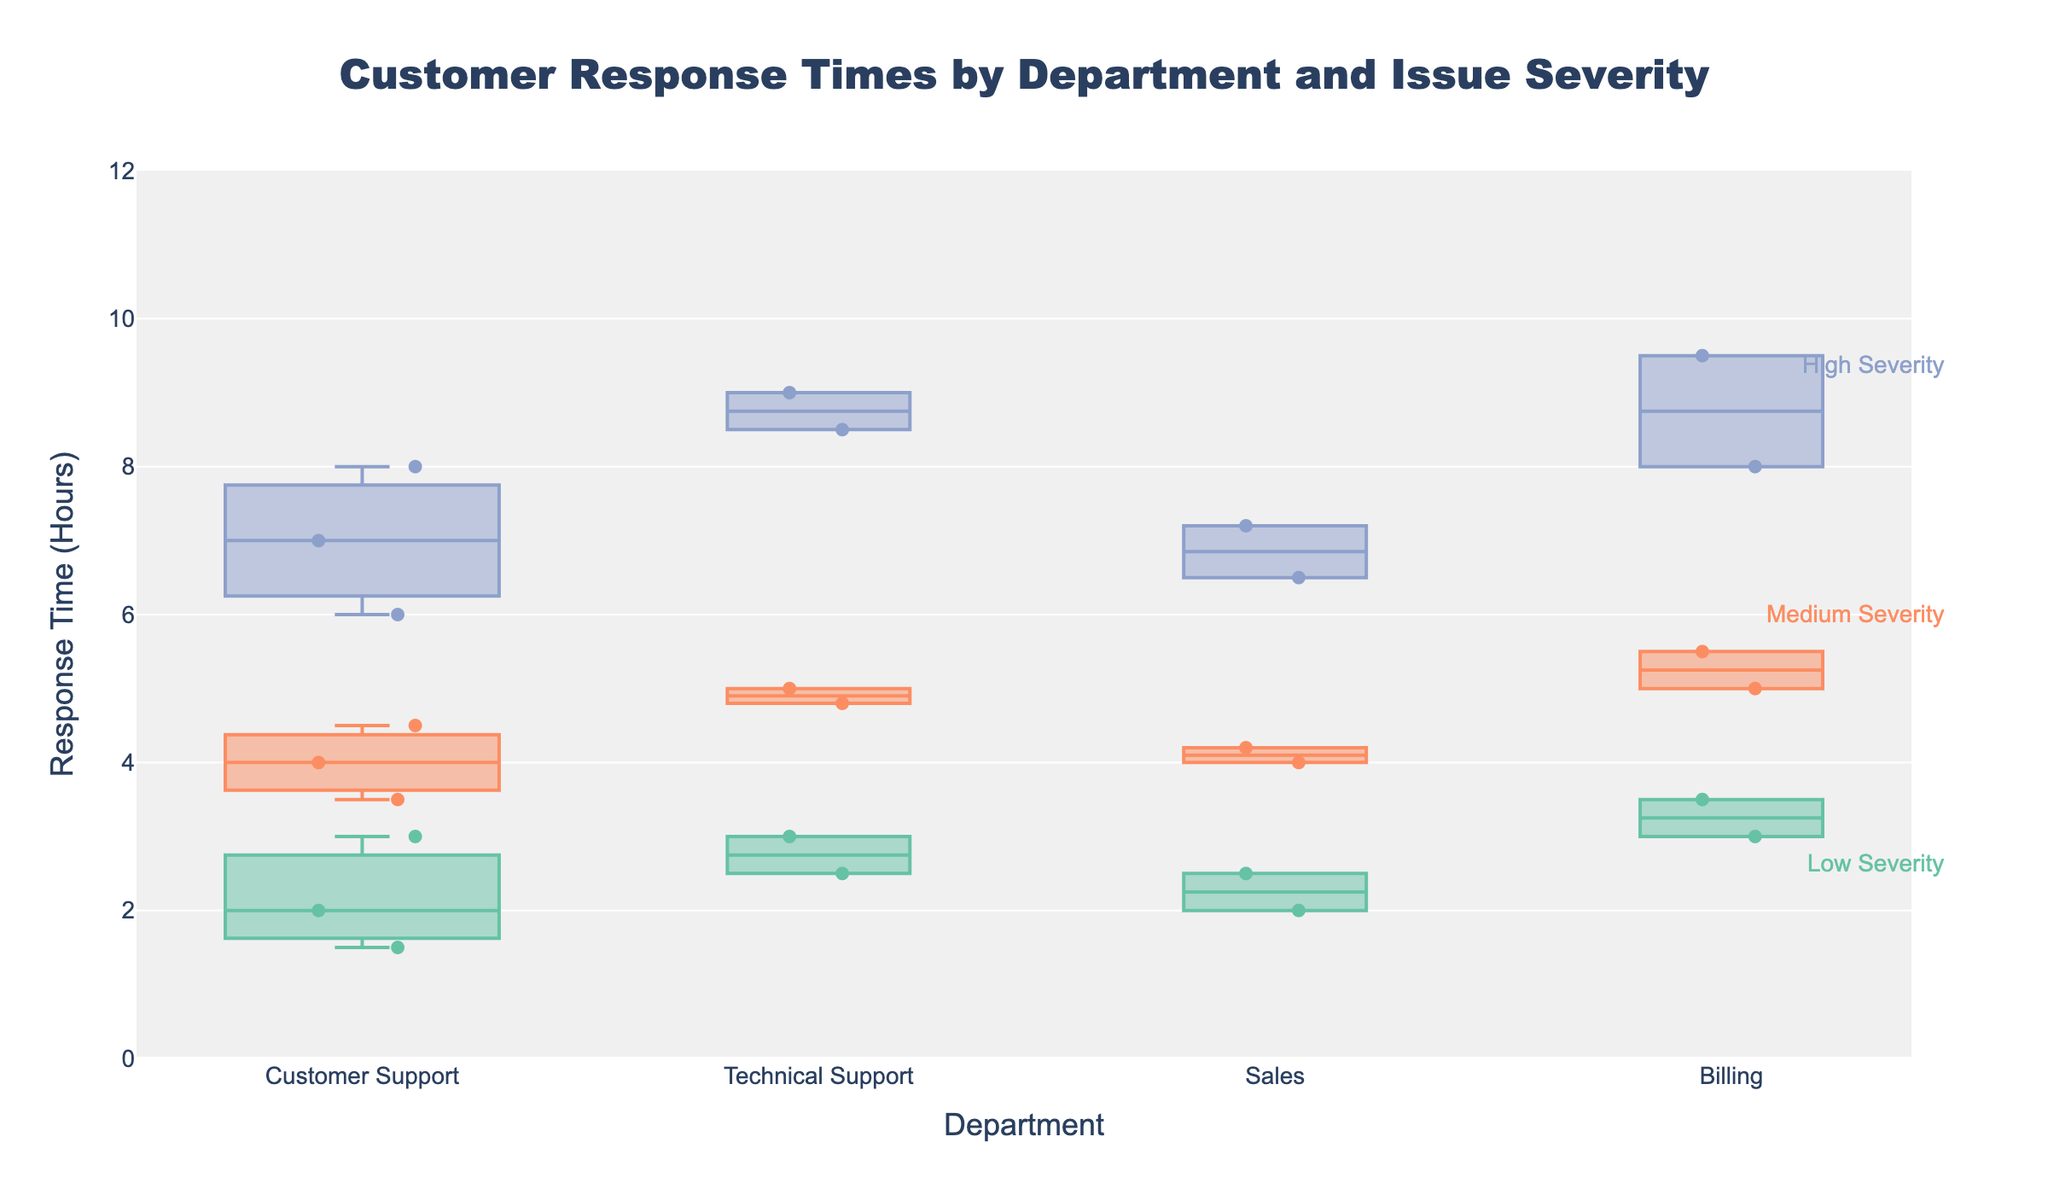What's the title of the figure? The title of the figure is prominently displayed at the top of the plot. Titles are important for giving viewers a clear understanding of what the figure represents. Here, the title helps identify the context of the data.
Answer: Customer Response Times by Department and Issue Severity What is the y-axis title? The y-axis title is located along the vertical axis of the figure and indicates the type of data measured. This helps the viewer understand what the response times are measured in.
Answer: Response Time (Hours) Which department has the widest box for High severity issues? To determine this, we look at the width of the boxes corresponding to High severity issues for each department. The wider the box, the more data points it has. Billing has a significantly wider box compared to other departments.
Answer: Billing Which severity level has the lowest median response time in Customer Support? By inspecting the median lines in the variable width box plots for Customer Support, the box with the lowest median line represents the lowest median response time. The Low severity level box in Customer Support has the lowest median.
Answer: Low How does the interquartile range (IQR) of Medium severity issues in Billing compare to Sales? The interquartile range (IQR) is the range between the first quartile (Q1) and the third quartile (Q3). By comparing the heights of the boxes for Medium severity issues in Billing and Sales, it is observed that Billing has a slightly larger IQR than Sales.
Answer: Billing has a larger IQR Are there more high severity instances in Technical Support or in Billing? The width of the box plots indicates the number of data points (instances). Comparing the widths of the High severity box plots, Billing has a wider plot than Technical Support, representing more instances.
Answer: Billing What is the maximum response time recorded for Technical Support on High severity issues? The maximum response time is represented by the top whisker or the highest data point. For Technical Support under High severity, the topmost whisker reaches approximately 9 hours.
Answer: 9 hours Which department shows the smallest range in response times for Low severity issues? The range for each severity level can be seen from the bottom to the top whisker (or the data points if there are outliers). For Low severity issues, Billing shows the smallest range.
Answer: Billing How does the median response time for Medium severity issues in Sales compare to Customer Support? To compare medians, one can visually inspect the line inside each box plot representing the median. For Medium severity issues, Sales has a slightly lower median response time compared to Customer Support.
Answer: Sales has a lower median 